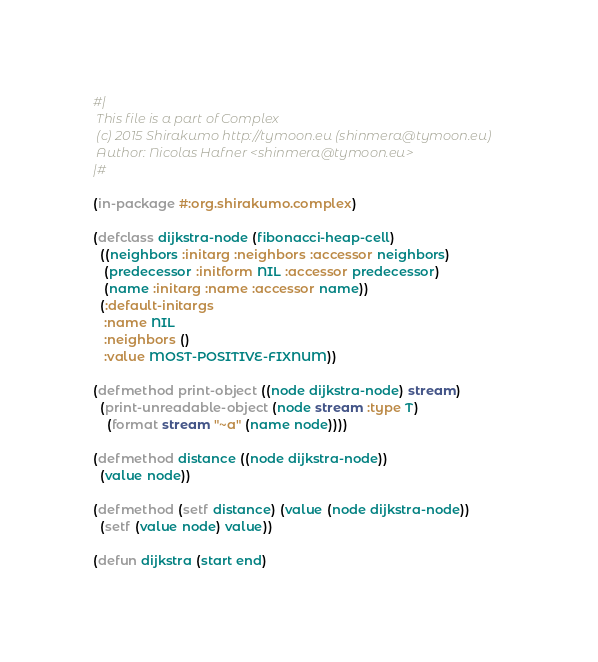Convert code to text. <code><loc_0><loc_0><loc_500><loc_500><_Lisp_>#|
 This file is a part of Complex
 (c) 2015 Shirakumo http://tymoon.eu (shinmera@tymoon.eu)
 Author: Nicolas Hafner <shinmera@tymoon.eu>
|#

(in-package #:org.shirakumo.complex)

(defclass dijkstra-node (fibonacci-heap-cell)
  ((neighbors :initarg :neighbors :accessor neighbors)
   (predecessor :initform NIL :accessor predecessor)
   (name :initarg :name :accessor name))
  (:default-initargs
   :name NIL
   :neighbors ()
   :value MOST-POSITIVE-FIXNUM))

(defmethod print-object ((node dijkstra-node) stream)
  (print-unreadable-object (node stream :type T)
    (format stream "~a" (name node))))

(defmethod distance ((node dijkstra-node))
  (value node))

(defmethod (setf distance) (value (node dijkstra-node))
  (setf (value node) value))

(defun dijkstra (start end)</code> 